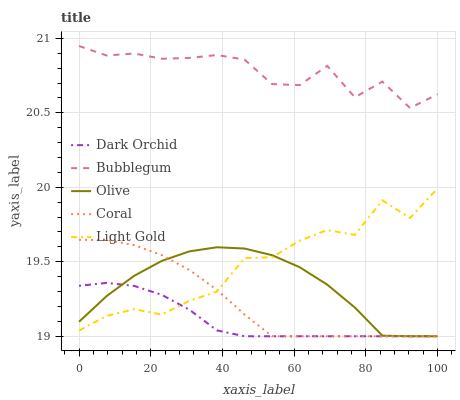Does Dark Orchid have the minimum area under the curve?
Answer yes or no. Yes. Does Bubblegum have the maximum area under the curve?
Answer yes or no. Yes. Does Coral have the minimum area under the curve?
Answer yes or no. No. Does Coral have the maximum area under the curve?
Answer yes or no. No. Is Dark Orchid the smoothest?
Answer yes or no. Yes. Is Bubblegum the roughest?
Answer yes or no. Yes. Is Coral the smoothest?
Answer yes or no. No. Is Coral the roughest?
Answer yes or no. No. Does Olive have the lowest value?
Answer yes or no. Yes. Does Light Gold have the lowest value?
Answer yes or no. No. Does Bubblegum have the highest value?
Answer yes or no. Yes. Does Coral have the highest value?
Answer yes or no. No. Is Olive less than Bubblegum?
Answer yes or no. Yes. Is Bubblegum greater than Light Gold?
Answer yes or no. Yes. Does Dark Orchid intersect Light Gold?
Answer yes or no. Yes. Is Dark Orchid less than Light Gold?
Answer yes or no. No. Is Dark Orchid greater than Light Gold?
Answer yes or no. No. Does Olive intersect Bubblegum?
Answer yes or no. No. 